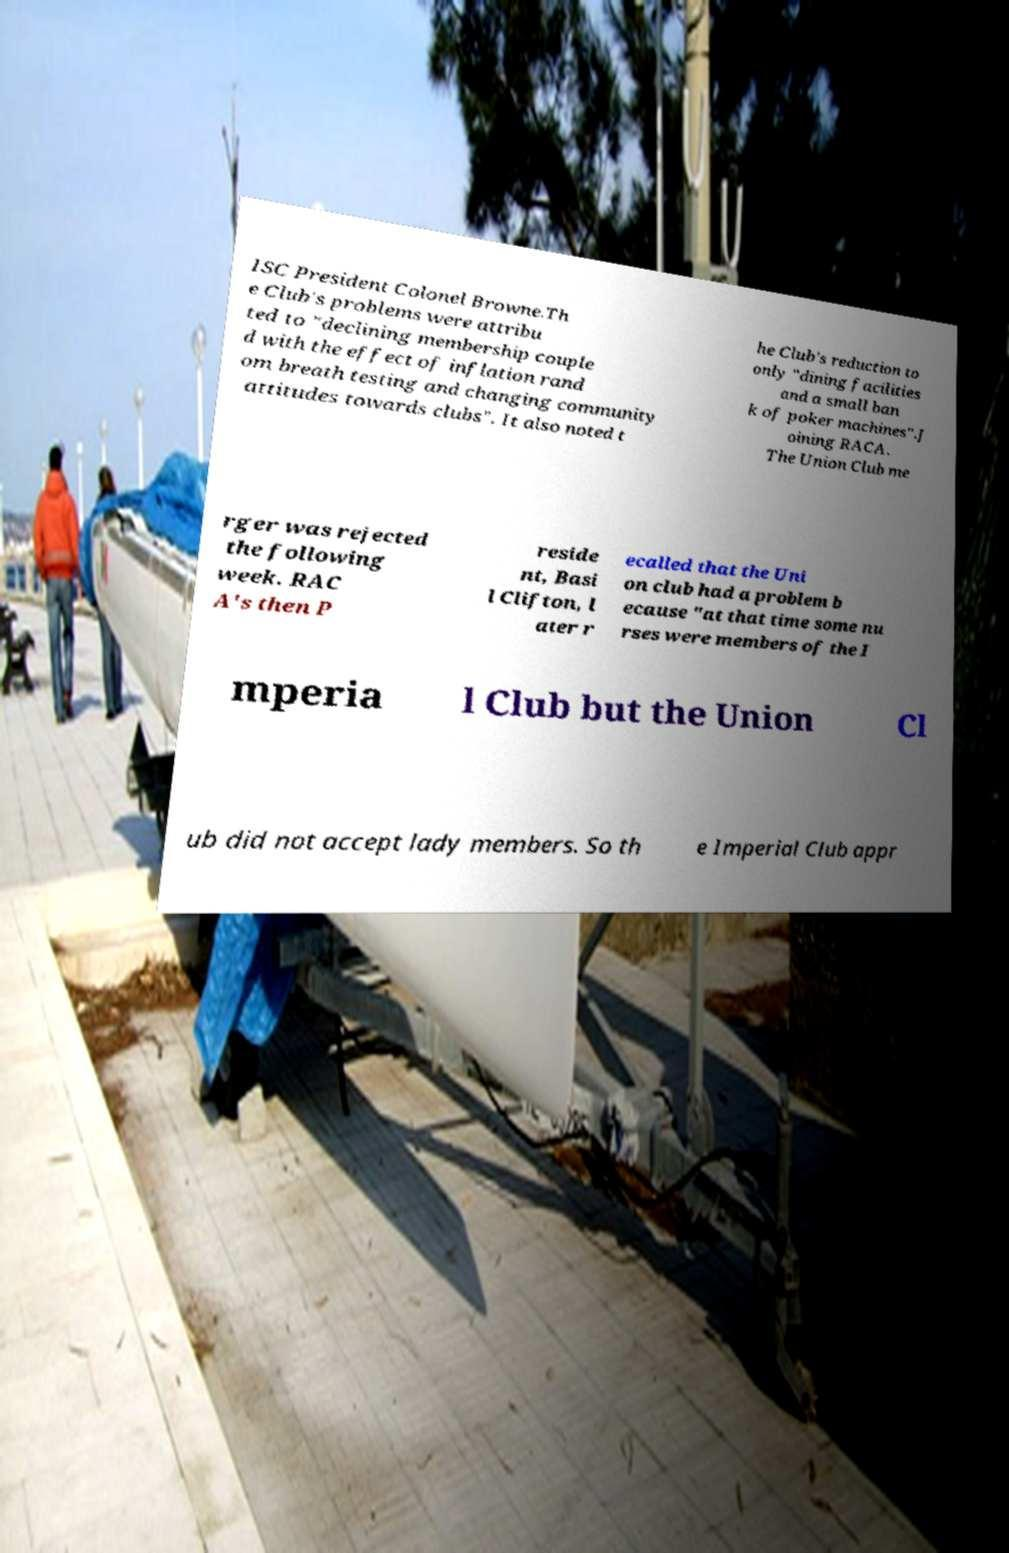For documentation purposes, I need the text within this image transcribed. Could you provide that? ISC President Colonel Browne.Th e Club's problems were attribu ted to "declining membership couple d with the effect of inflation rand om breath testing and changing community attitudes towards clubs". It also noted t he Club's reduction to only "dining facilities and a small ban k of poker machines".J oining RACA. The Union Club me rger was rejected the following week. RAC A's then P reside nt, Basi l Clifton, l ater r ecalled that the Uni on club had a problem b ecause "at that time some nu rses were members of the I mperia l Club but the Union Cl ub did not accept lady members. So th e Imperial Club appr 